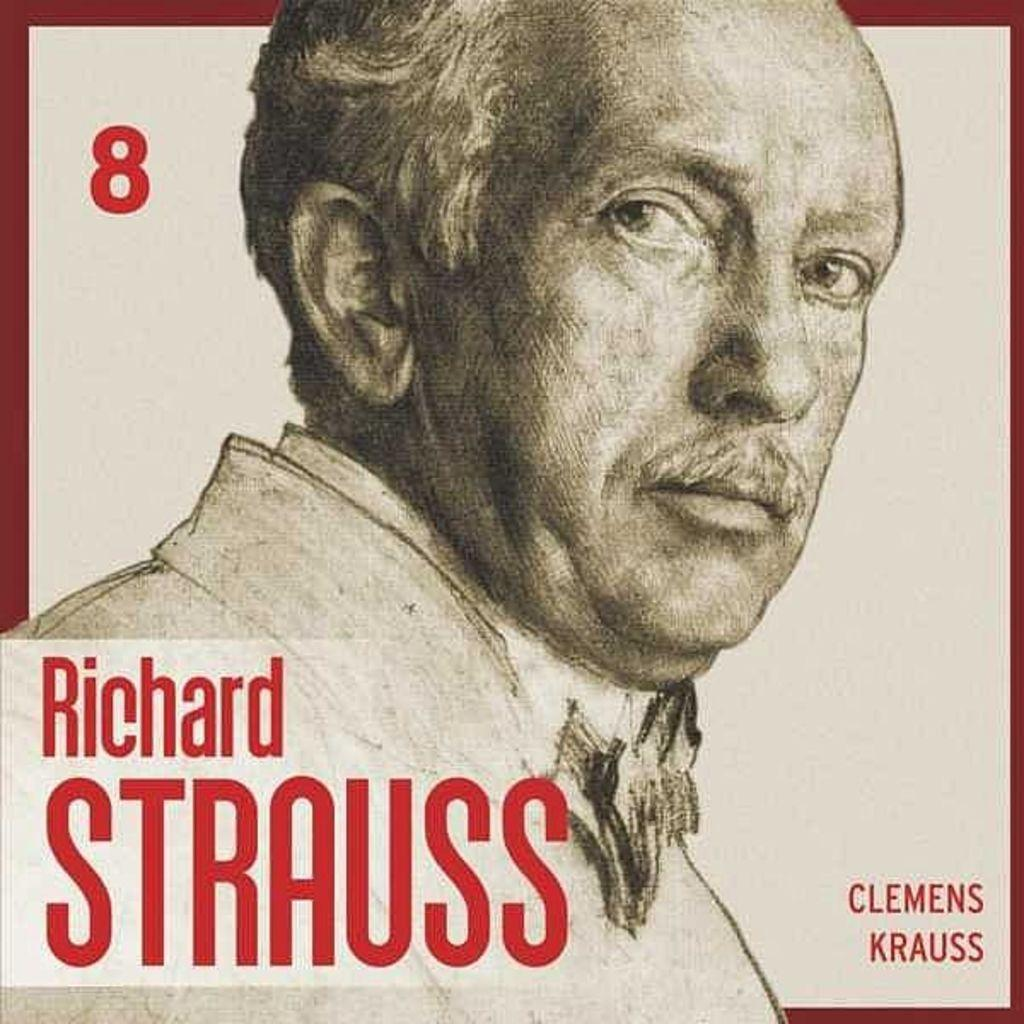What is the main subject of the image? There is a person in the image. What else can be seen in the image besides the person? There is text in the image. What color is the background of the image? The background of the image is white. What type of object might the image be a part of? The image appears to be a photo frame. How many bikes are visible in the image? There are no bikes present in the image. What type of powder is being used by the person in the image? There is no powder visible in the image, and the person's actions are not described. 